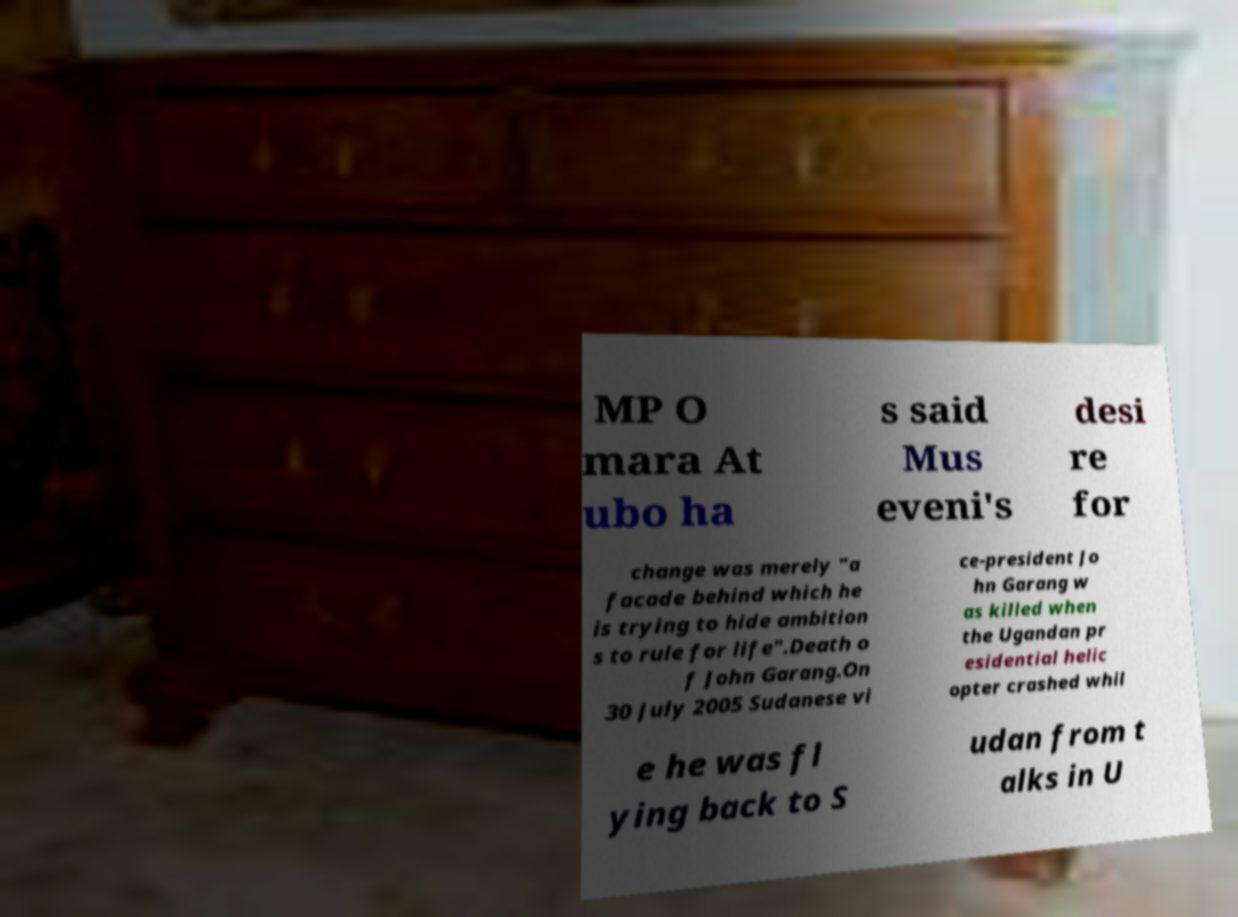Can you accurately transcribe the text from the provided image for me? MP O mara At ubo ha s said Mus eveni's desi re for change was merely "a facade behind which he is trying to hide ambition s to rule for life".Death o f John Garang.On 30 July 2005 Sudanese vi ce-president Jo hn Garang w as killed when the Ugandan pr esidential helic opter crashed whil e he was fl ying back to S udan from t alks in U 